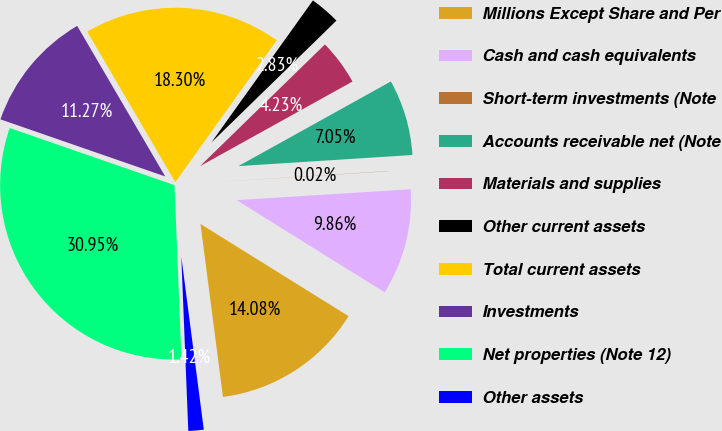Convert chart to OTSL. <chart><loc_0><loc_0><loc_500><loc_500><pie_chart><fcel>Millions Except Share and Per<fcel>Cash and cash equivalents<fcel>Short-term investments (Note<fcel>Accounts receivable net (Note<fcel>Materials and supplies<fcel>Other current assets<fcel>Total current assets<fcel>Investments<fcel>Net properties (Note 12)<fcel>Other assets<nl><fcel>14.08%<fcel>9.86%<fcel>0.02%<fcel>7.05%<fcel>4.23%<fcel>2.83%<fcel>18.3%<fcel>11.27%<fcel>30.95%<fcel>1.42%<nl></chart> 